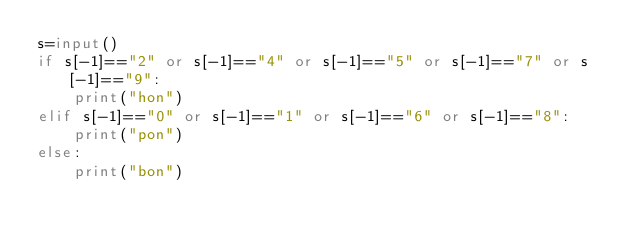<code> <loc_0><loc_0><loc_500><loc_500><_Python_>s=input()
if s[-1]=="2" or s[-1]=="4" or s[-1]=="5" or s[-1]=="7" or s[-1]=="9":
    print("hon")
elif s[-1]=="0" or s[-1]=="1" or s[-1]=="6" or s[-1]=="8":
    print("pon")
else:
    print("bon")</code> 